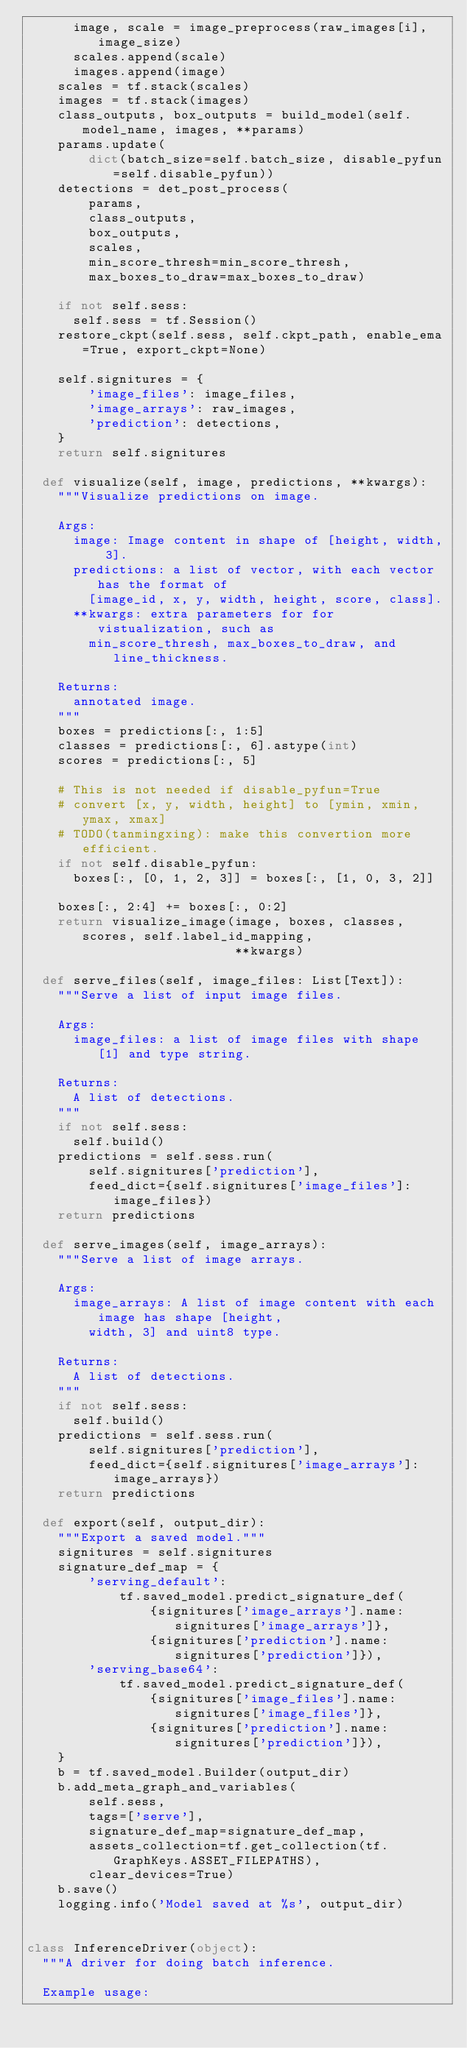<code> <loc_0><loc_0><loc_500><loc_500><_Python_>      image, scale = image_preprocess(raw_images[i], image_size)
      scales.append(scale)
      images.append(image)
    scales = tf.stack(scales)
    images = tf.stack(images)
    class_outputs, box_outputs = build_model(self.model_name, images, **params)
    params.update(
        dict(batch_size=self.batch_size, disable_pyfun=self.disable_pyfun))
    detections = det_post_process(
        params,
        class_outputs,
        box_outputs,
        scales,
        min_score_thresh=min_score_thresh,
        max_boxes_to_draw=max_boxes_to_draw)

    if not self.sess:
      self.sess = tf.Session()
    restore_ckpt(self.sess, self.ckpt_path, enable_ema=True, export_ckpt=None)

    self.signitures = {
        'image_files': image_files,
        'image_arrays': raw_images,
        'prediction': detections,
    }
    return self.signitures

  def visualize(self, image, predictions, **kwargs):
    """Visualize predictions on image.

    Args:
      image: Image content in shape of [height, width, 3].
      predictions: a list of vector, with each vector has the format of
        [image_id, x, y, width, height, score, class].
      **kwargs: extra parameters for for vistualization, such as
        min_score_thresh, max_boxes_to_draw, and line_thickness.

    Returns:
      annotated image.
    """
    boxes = predictions[:, 1:5]
    classes = predictions[:, 6].astype(int)
    scores = predictions[:, 5]

    # This is not needed if disable_pyfun=True
    # convert [x, y, width, height] to [ymin, xmin, ymax, xmax]
    # TODO(tanmingxing): make this convertion more efficient.
    if not self.disable_pyfun:
      boxes[:, [0, 1, 2, 3]] = boxes[:, [1, 0, 3, 2]]

    boxes[:, 2:4] += boxes[:, 0:2]
    return visualize_image(image, boxes, classes, scores, self.label_id_mapping,
                           **kwargs)

  def serve_files(self, image_files: List[Text]):
    """Serve a list of input image files.

    Args:
      image_files: a list of image files with shape [1] and type string.

    Returns:
      A list of detections.
    """
    if not self.sess:
      self.build()
    predictions = self.sess.run(
        self.signitures['prediction'],
        feed_dict={self.signitures['image_files']: image_files})
    return predictions

  def serve_images(self, image_arrays):
    """Serve a list of image arrays.

    Args:
      image_arrays: A list of image content with each image has shape [height,
        width, 3] and uint8 type.

    Returns:
      A list of detections.
    """
    if not self.sess:
      self.build()
    predictions = self.sess.run(
        self.signitures['prediction'],
        feed_dict={self.signitures['image_arrays']: image_arrays})
    return predictions

  def export(self, output_dir):
    """Export a saved model."""
    signitures = self.signitures
    signature_def_map = {
        'serving_default':
            tf.saved_model.predict_signature_def(
                {signitures['image_arrays'].name: signitures['image_arrays']},
                {signitures['prediction'].name: signitures['prediction']}),
        'serving_base64':
            tf.saved_model.predict_signature_def(
                {signitures['image_files'].name: signitures['image_files']},
                {signitures['prediction'].name: signitures['prediction']}),
    }
    b = tf.saved_model.Builder(output_dir)
    b.add_meta_graph_and_variables(
        self.sess,
        tags=['serve'],
        signature_def_map=signature_def_map,
        assets_collection=tf.get_collection(tf.GraphKeys.ASSET_FILEPATHS),
        clear_devices=True)
    b.save()
    logging.info('Model saved at %s', output_dir)


class InferenceDriver(object):
  """A driver for doing batch inference.

  Example usage:
</code> 